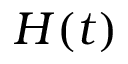Convert formula to latex. <formula><loc_0><loc_0><loc_500><loc_500>H ( t )</formula> 